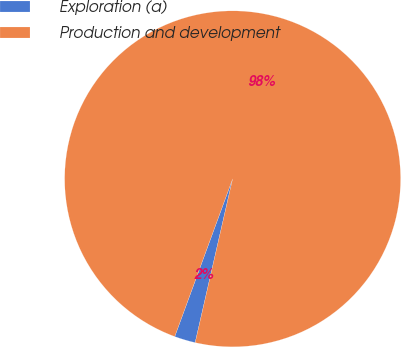<chart> <loc_0><loc_0><loc_500><loc_500><pie_chart><fcel>Exploration (a)<fcel>Production and development<nl><fcel>2.02%<fcel>97.98%<nl></chart> 